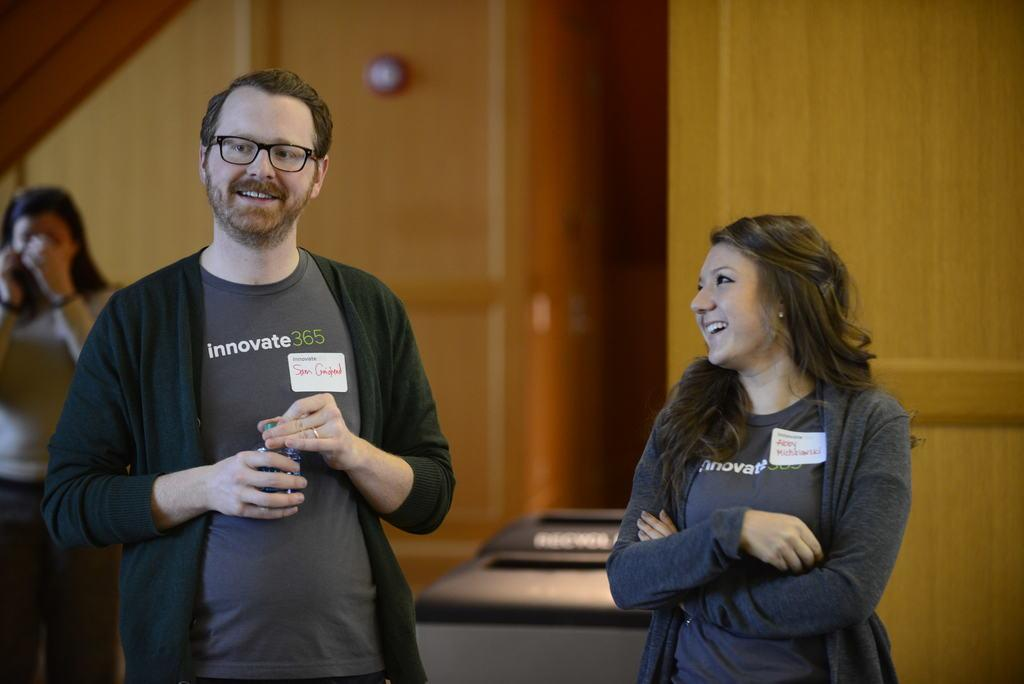How many people are present in the image? There are two people, a man and a woman, standing in the image. What are the expressions on their faces? Both the man and the woman are smiling. What type of structure can be seen in the image? There appears to be a wooden wall in the image. Can you describe the woman in the background? There is another woman standing in the background of the image. What type of coil is being used by the parent in the image? There is no coil or parent present in the image. What type of lace is being worn by the women in the image? The provided facts do not mention any lace being worn by the women in the image. 